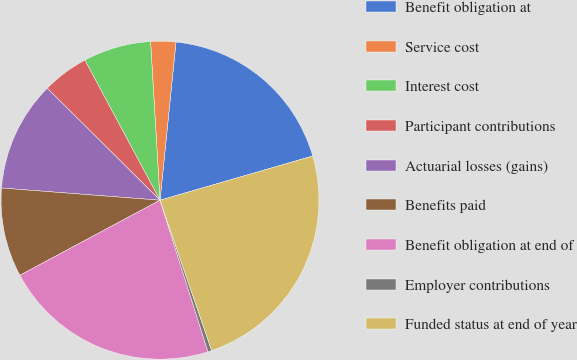Convert chart. <chart><loc_0><loc_0><loc_500><loc_500><pie_chart><fcel>Benefit obligation at<fcel>Service cost<fcel>Interest cost<fcel>Participant contributions<fcel>Actuarial losses (gains)<fcel>Benefits paid<fcel>Benefit obligation at end of<fcel>Employer contributions<fcel>Funded status at end of year<nl><fcel>18.91%<fcel>2.55%<fcel>6.89%<fcel>4.72%<fcel>11.22%<fcel>9.05%<fcel>22.05%<fcel>0.39%<fcel>24.22%<nl></chart> 